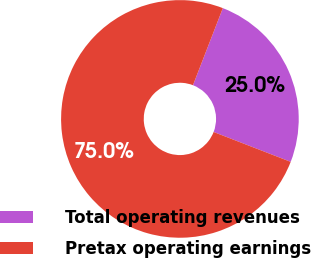Convert chart. <chart><loc_0><loc_0><loc_500><loc_500><pie_chart><fcel>Total operating revenues<fcel>Pretax operating earnings<nl><fcel>25.0%<fcel>75.0%<nl></chart> 